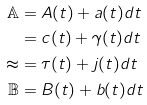<formula> <loc_0><loc_0><loc_500><loc_500>\mathbb { A } & = A ( t ) + a ( t ) d t \\ \mathbb { c } & = c ( t ) + \gamma ( t ) d t \\ \mathbb { t } & = \tau ( t ) + j ( t ) d t \\ \mathbb { B } & = B ( t ) + b ( t ) d t</formula> 